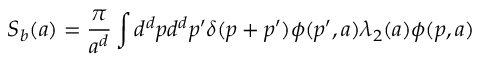<formula> <loc_0><loc_0><loc_500><loc_500>S _ { b } ( a ) = \frac { \pi } { a ^ { d } } \int d ^ { d } p d ^ { d } p ^ { \prime } \delta ( p + p ^ { \prime } ) \phi ( p ^ { \prime } , a ) \lambda _ { 2 } ( a ) \phi ( p , a )</formula> 